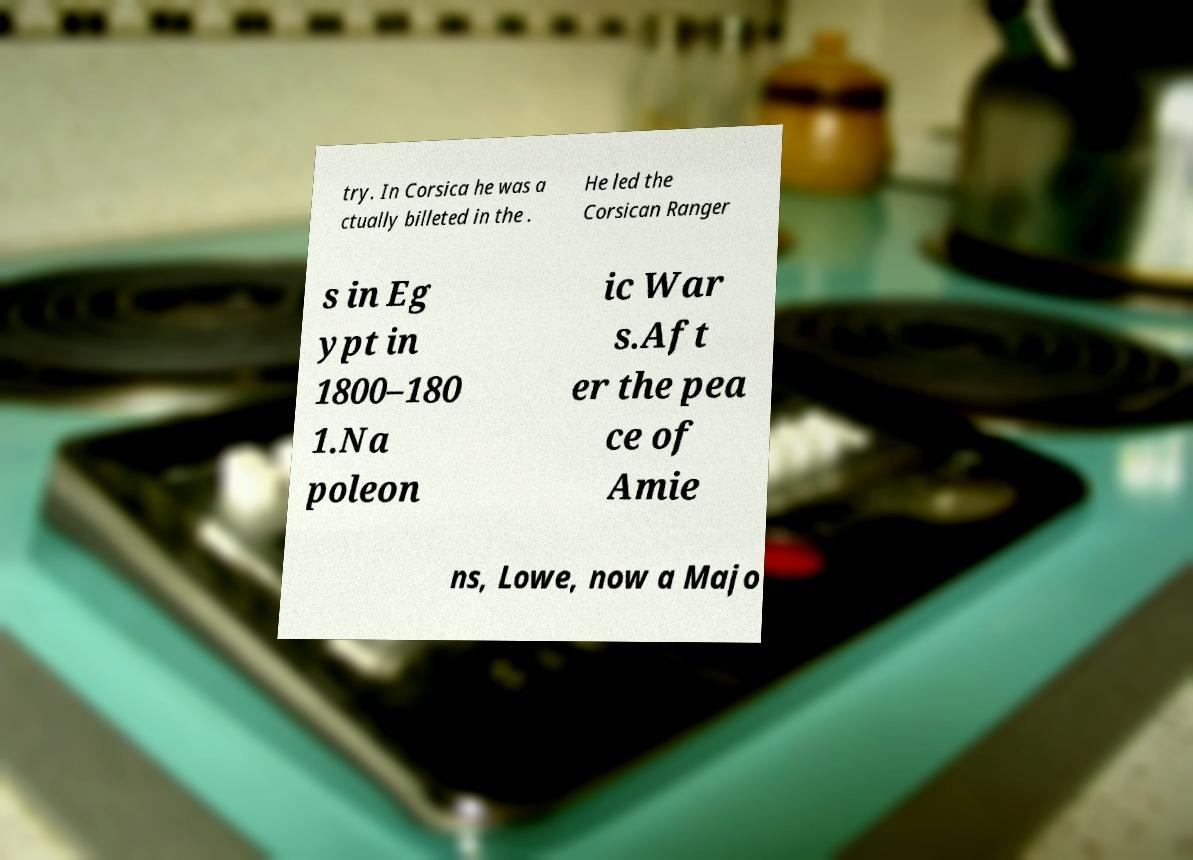I need the written content from this picture converted into text. Can you do that? try. In Corsica he was a ctually billeted in the . He led the Corsican Ranger s in Eg ypt in 1800–180 1.Na poleon ic War s.Aft er the pea ce of Amie ns, Lowe, now a Majo 